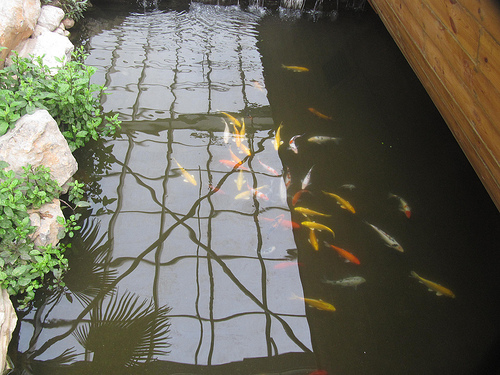<image>
Is there a rocks in the water? No. The rocks is not contained within the water. These objects have a different spatial relationship. 